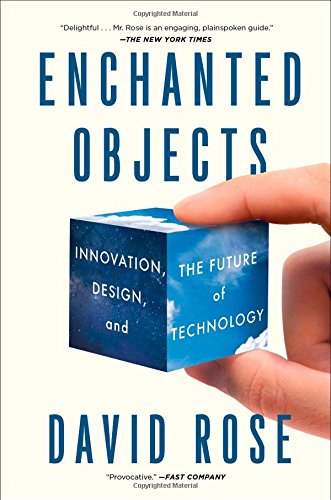How might this book inspire designers or technologists? This book serves as a repository of inspiration, showing how to think outside the box when integrating technology into design. It encourages a proactive approach in creating more engaging, intuitive, and delightful user experiences with objects that make up our everyday life. 